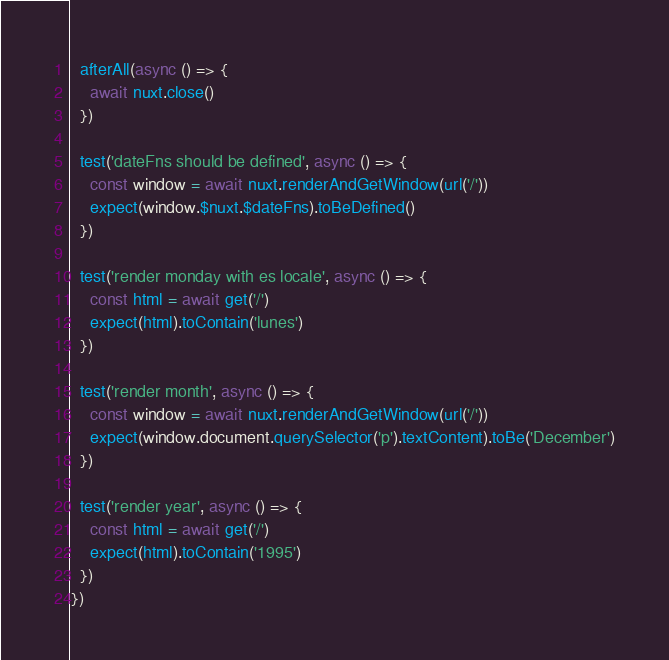<code> <loc_0><loc_0><loc_500><loc_500><_JavaScript_>
  afterAll(async () => {
    await nuxt.close()
  })

  test('dateFns should be defined', async () => {
    const window = await nuxt.renderAndGetWindow(url('/'))
    expect(window.$nuxt.$dateFns).toBeDefined()
  })

  test('render monday with es locale', async () => {
    const html = await get('/')
    expect(html).toContain('lunes')
  })

  test('render month', async () => {
    const window = await nuxt.renderAndGetWindow(url('/'))
    expect(window.document.querySelector('p').textContent).toBe('December')
  })

  test('render year', async () => {
    const html = await get('/')
    expect(html).toContain('1995')
  })
})
</code> 